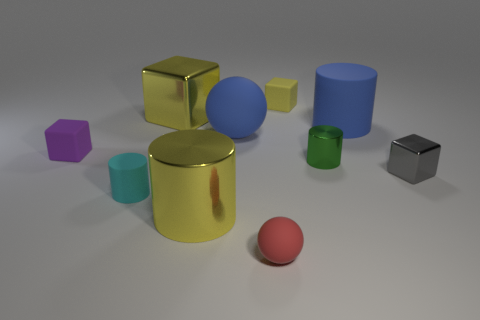Subtract 1 cubes. How many cubes are left? 3 Subtract all cubes. How many objects are left? 6 Subtract all large blocks. Subtract all tiny metallic things. How many objects are left? 7 Add 1 large cubes. How many large cubes are left? 2 Add 9 tiny red rubber spheres. How many tiny red rubber spheres exist? 10 Subtract 0 gray cylinders. How many objects are left? 10 